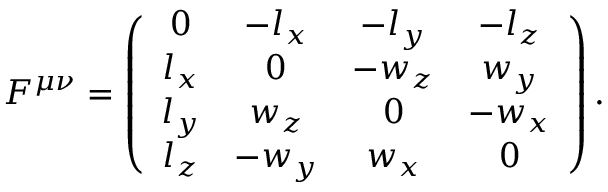<formula> <loc_0><loc_0><loc_500><loc_500>F ^ { \mu \nu } = \left ( \begin{array} { c c c c } { 0 } & { { - l _ { x } } } & { { - l _ { y } } } & { { - l _ { z } } } \\ { { l _ { x } } } & { 0 } & { { - w _ { z } } } & { { w _ { y } } } \\ { { l _ { y } } } & { { w _ { z } } } & { 0 } & { { - w _ { x } } } \\ { { l _ { z } } } & { { - w _ { y } } } & { { w _ { x } } } & { 0 } \end{array} \right ) .</formula> 